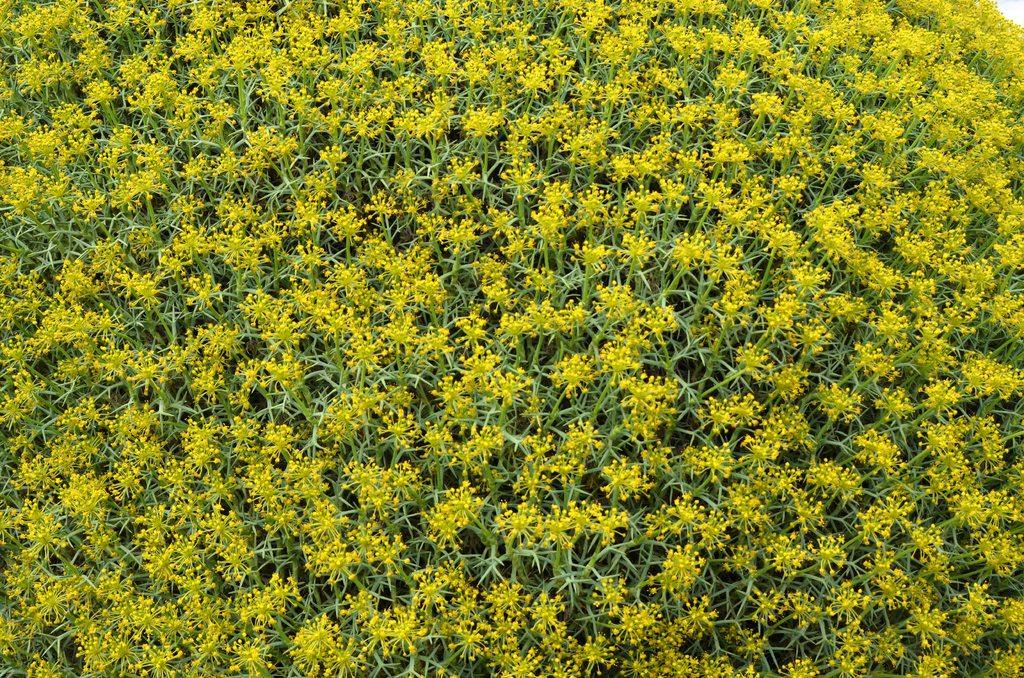What color are the flowers in the image? The flowers in the image are yellow. What type of plants do the flowers grow on? The flowers are on plants. What is the title of the play being performed on the stage in the image? There is no stage or play present in the image; it features yellow flowers on plants. What type of wood can be seen in the image? There is no wood visible in the image; it features yellow flowers on plants. 